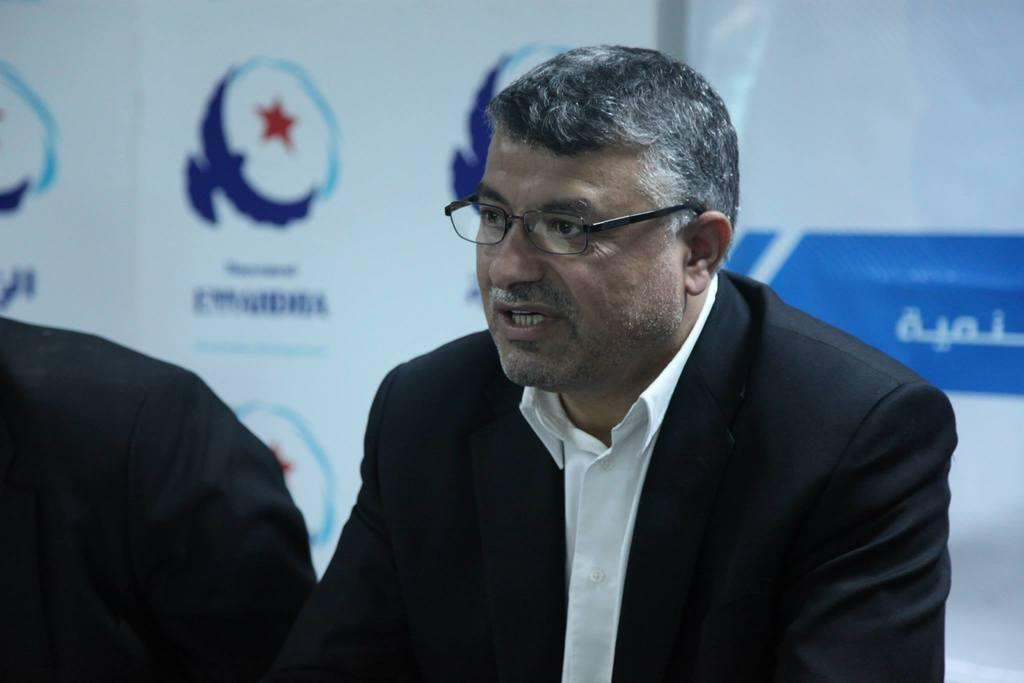Who or what is the main subject in the image? There is a person in the image. What can be observed about the person's appearance? The person is wearing spectacles. What is visible in the background of the image? There is a poster with images and text in the background. What is the color and location of the object on the left side of the image? There is a black colored object on the left side of the image. What type of neck is the person wearing in the image? There is no neck visible in the image; the person is wearing spectacles, not a neck. 